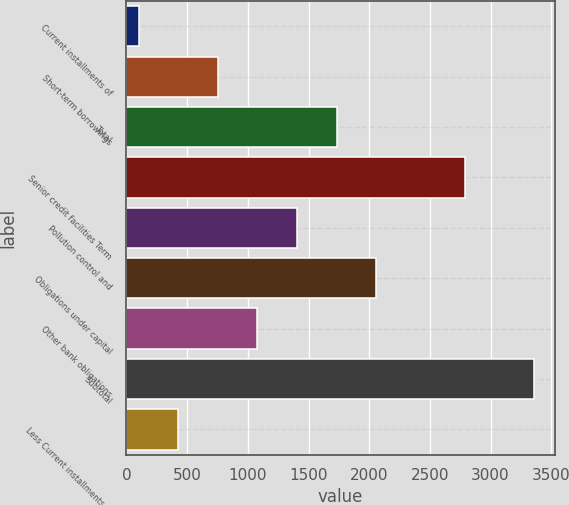Convert chart. <chart><loc_0><loc_0><loc_500><loc_500><bar_chart><fcel>Current installments of<fcel>Short-term borrowings<fcel>Total<fcel>Senior credit facilities Term<fcel>Pollution control and<fcel>Obligations under capital<fcel>Other bank obligations<fcel>Subtotal<fcel>Less Current installments of<nl><fcel>102<fcel>753.8<fcel>1731.5<fcel>2785<fcel>1405.6<fcel>2057.4<fcel>1079.7<fcel>3361<fcel>427.9<nl></chart> 